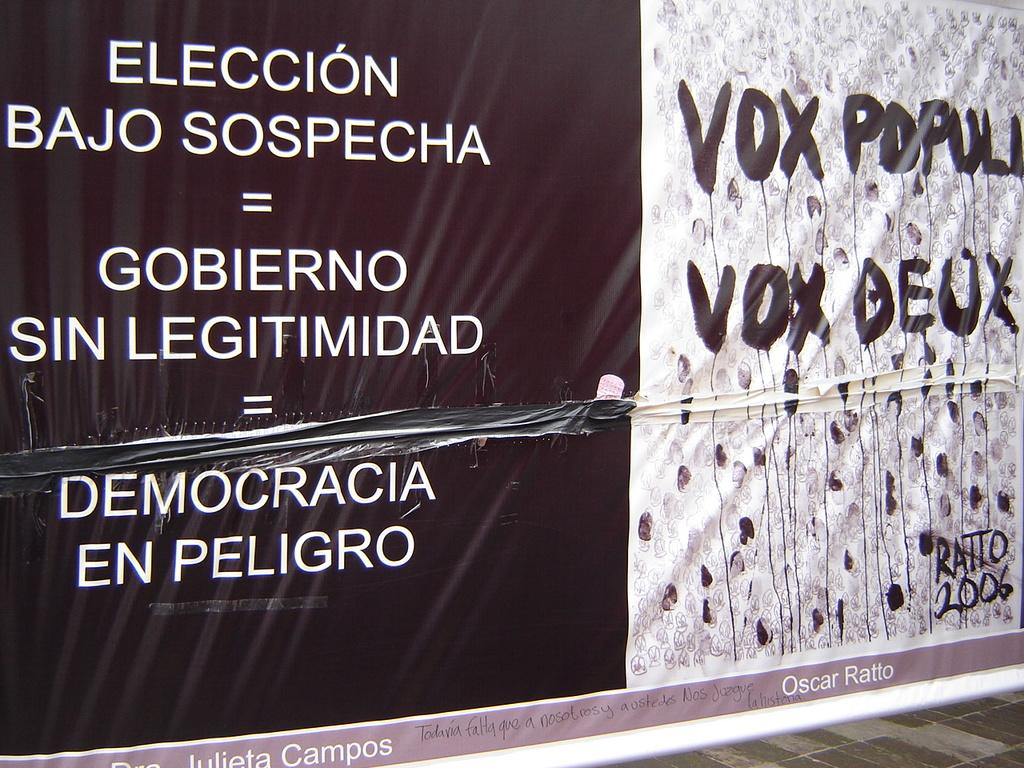Provide a one-sentence caption for the provided image. sign that is black on left and white on right and has the word vox on it twice. 